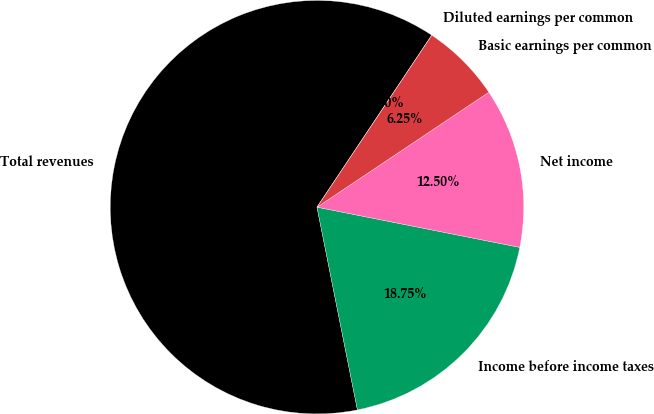Convert chart to OTSL. <chart><loc_0><loc_0><loc_500><loc_500><pie_chart><fcel>Total revenues<fcel>Income before income taxes<fcel>Net income<fcel>Basic earnings per common<fcel>Diluted earnings per common<nl><fcel>62.5%<fcel>18.75%<fcel>12.5%<fcel>6.25%<fcel>0.0%<nl></chart> 